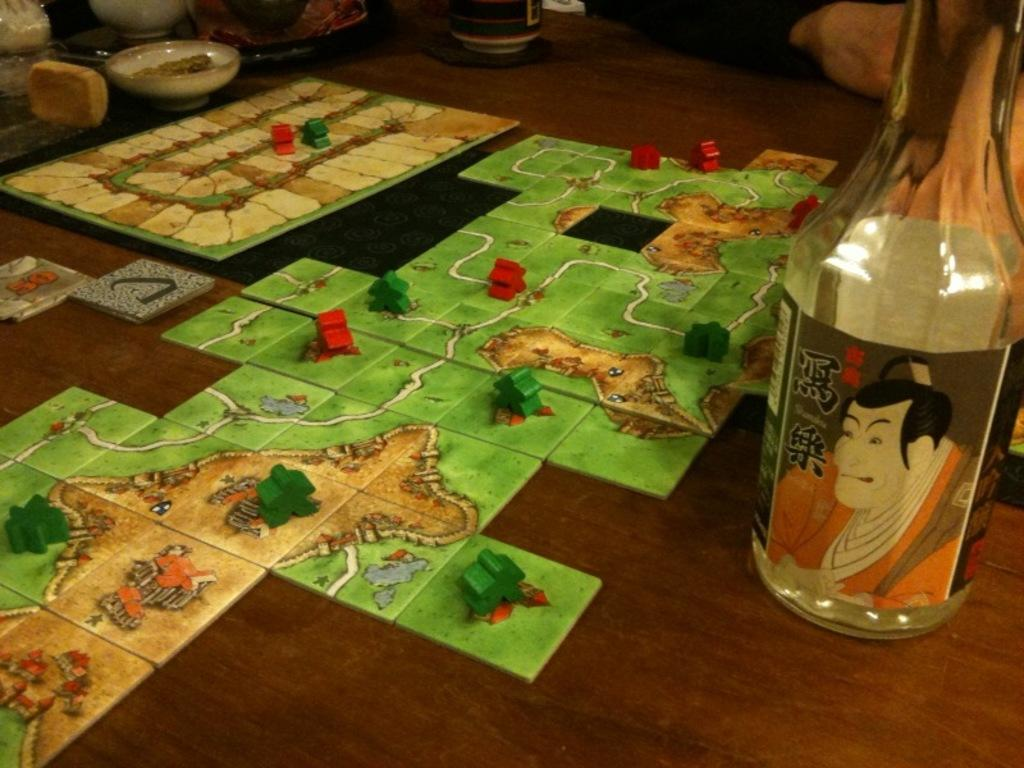What is the main subject of the image? The main subject of the image is a puzzle chart. Can you describe any other objects in the image? Yes, there is a bottle on the table in the image. How many bikes are parked on the floor in the image? There are no bikes present in the image. Is there a cushion on the table next to the bottle in the image? There is no mention of a cushion in the image, only a bottle on the table. 